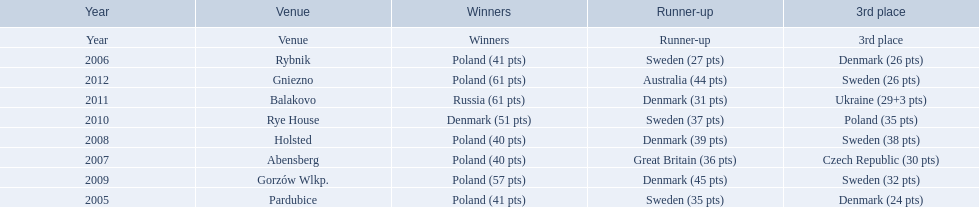In what years did denmark place in the top 3 in the team speedway junior world championship? 2005, 2006, 2008, 2009, 2010, 2011. What in what year did denmark come withing 2 points of placing higher in the standings? 2006. What place did denmark receive the year they missed higher ranking by only 2 points? 3rd place. 